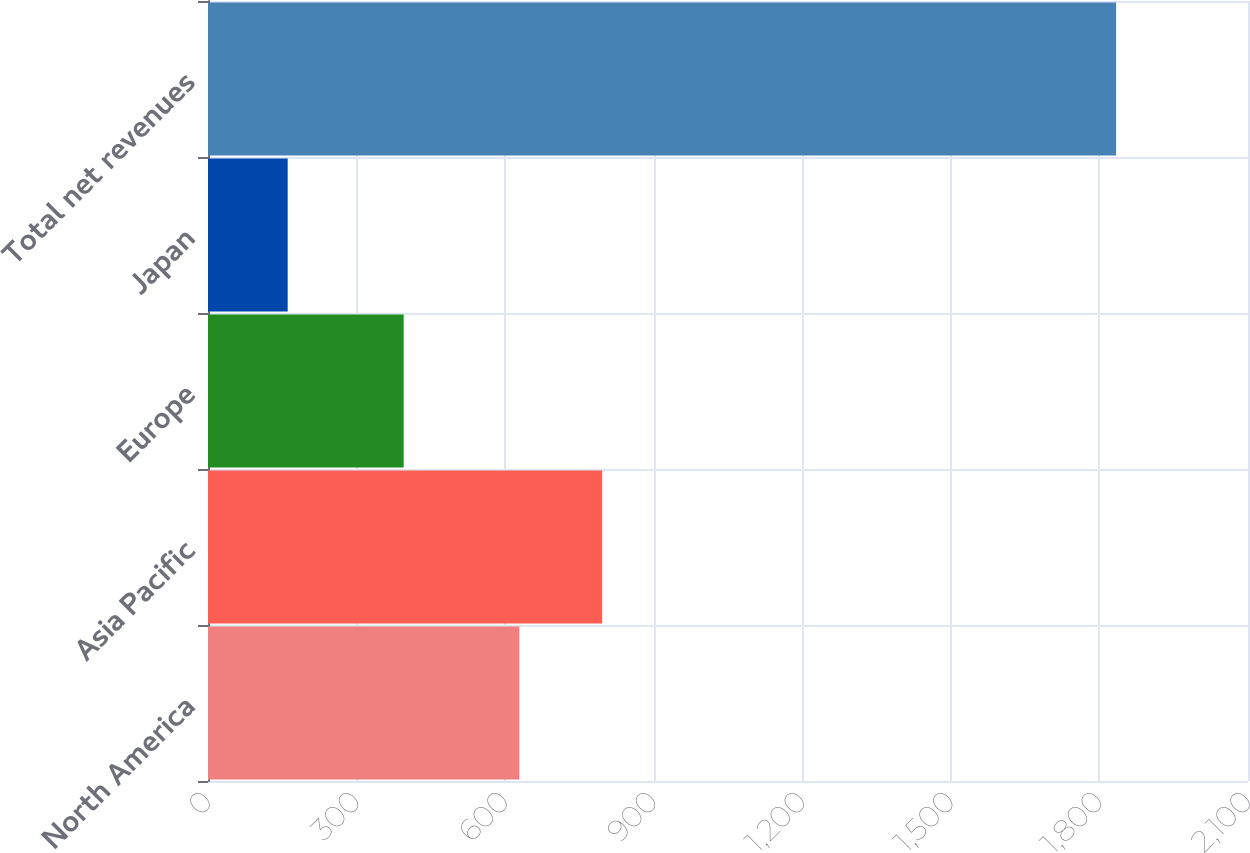Convert chart. <chart><loc_0><loc_0><loc_500><loc_500><bar_chart><fcel>North America<fcel>Asia Pacific<fcel>Europe<fcel>Japan<fcel>Total net revenues<nl><fcel>628.5<fcel>795.77<fcel>395.1<fcel>160.9<fcel>1833.6<nl></chart> 